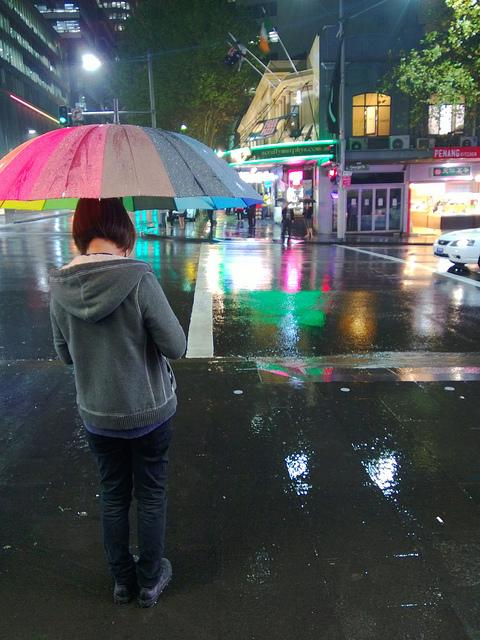What does the person standing here wait to see? Please explain your reasoning. walk light. She is at an intersection and the light is red 